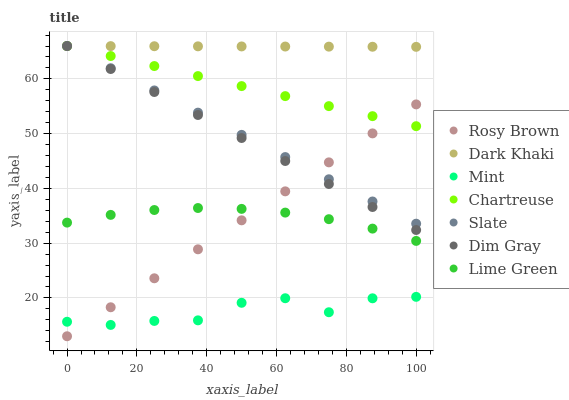Does Mint have the minimum area under the curve?
Answer yes or no. Yes. Does Dark Khaki have the maximum area under the curve?
Answer yes or no. Yes. Does Lime Green have the minimum area under the curve?
Answer yes or no. No. Does Lime Green have the maximum area under the curve?
Answer yes or no. No. Is Chartreuse the smoothest?
Answer yes or no. Yes. Is Mint the roughest?
Answer yes or no. Yes. Is Lime Green the smoothest?
Answer yes or no. No. Is Lime Green the roughest?
Answer yes or no. No. Does Rosy Brown have the lowest value?
Answer yes or no. Yes. Does Lime Green have the lowest value?
Answer yes or no. No. Does Chartreuse have the highest value?
Answer yes or no. Yes. Does Lime Green have the highest value?
Answer yes or no. No. Is Rosy Brown less than Dark Khaki?
Answer yes or no. Yes. Is Dark Khaki greater than Mint?
Answer yes or no. Yes. Does Rosy Brown intersect Dim Gray?
Answer yes or no. Yes. Is Rosy Brown less than Dim Gray?
Answer yes or no. No. Is Rosy Brown greater than Dim Gray?
Answer yes or no. No. Does Rosy Brown intersect Dark Khaki?
Answer yes or no. No. 